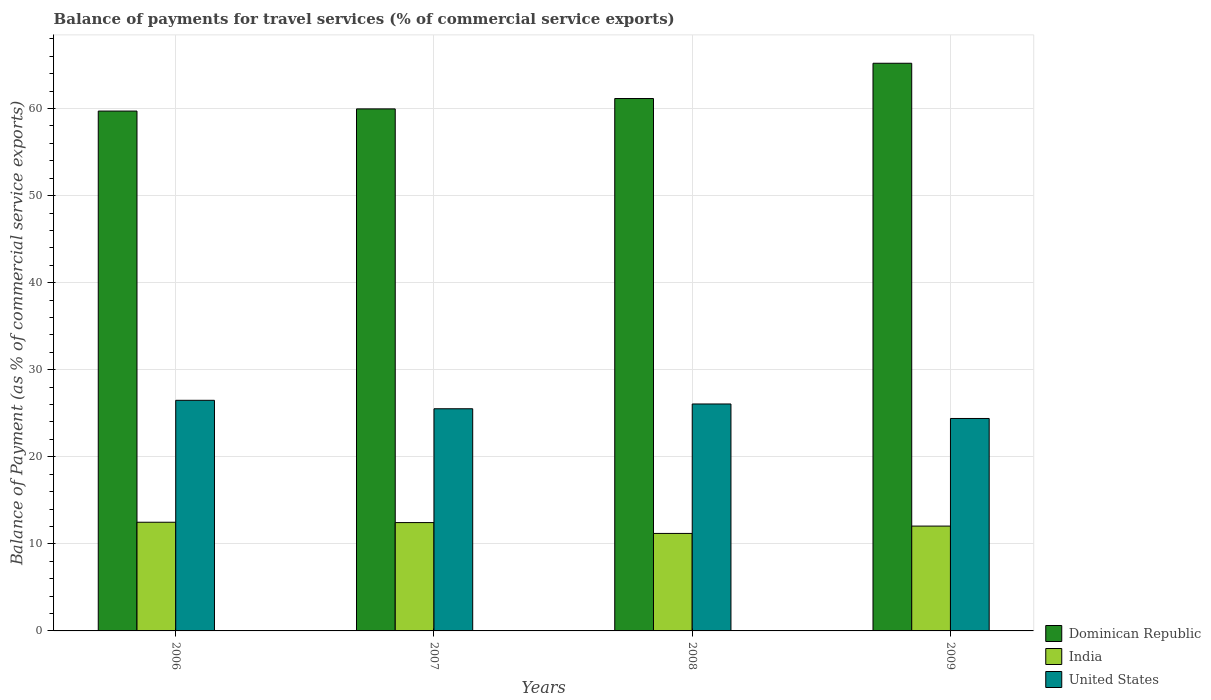How many groups of bars are there?
Provide a succinct answer. 4. How many bars are there on the 1st tick from the left?
Provide a succinct answer. 3. In how many cases, is the number of bars for a given year not equal to the number of legend labels?
Make the answer very short. 0. What is the balance of payments for travel services in United States in 2009?
Your answer should be very brief. 24.4. Across all years, what is the maximum balance of payments for travel services in Dominican Republic?
Provide a short and direct response. 65.2. Across all years, what is the minimum balance of payments for travel services in United States?
Keep it short and to the point. 24.4. In which year was the balance of payments for travel services in Dominican Republic maximum?
Offer a terse response. 2009. What is the total balance of payments for travel services in India in the graph?
Offer a very short reply. 48.16. What is the difference between the balance of payments for travel services in Dominican Republic in 2006 and that in 2008?
Keep it short and to the point. -1.44. What is the difference between the balance of payments for travel services in India in 2008 and the balance of payments for travel services in Dominican Republic in 2007?
Offer a very short reply. -48.76. What is the average balance of payments for travel services in Dominican Republic per year?
Your response must be concise. 61.5. In the year 2008, what is the difference between the balance of payments for travel services in United States and balance of payments for travel services in India?
Give a very brief answer. 14.87. What is the ratio of the balance of payments for travel services in India in 2006 to that in 2009?
Your answer should be compact. 1.04. Is the balance of payments for travel services in India in 2006 less than that in 2007?
Your answer should be compact. No. Is the difference between the balance of payments for travel services in United States in 2008 and 2009 greater than the difference between the balance of payments for travel services in India in 2008 and 2009?
Offer a terse response. Yes. What is the difference between the highest and the second highest balance of payments for travel services in India?
Ensure brevity in your answer.  0.04. What is the difference between the highest and the lowest balance of payments for travel services in India?
Give a very brief answer. 1.29. Is the sum of the balance of payments for travel services in India in 2006 and 2008 greater than the maximum balance of payments for travel services in Dominican Republic across all years?
Ensure brevity in your answer.  No. Is it the case that in every year, the sum of the balance of payments for travel services in India and balance of payments for travel services in United States is greater than the balance of payments for travel services in Dominican Republic?
Keep it short and to the point. No. Are all the bars in the graph horizontal?
Make the answer very short. No. How many years are there in the graph?
Offer a very short reply. 4. What is the difference between two consecutive major ticks on the Y-axis?
Offer a terse response. 10. Does the graph contain any zero values?
Your answer should be compact. No. How are the legend labels stacked?
Your answer should be very brief. Vertical. What is the title of the graph?
Offer a terse response. Balance of payments for travel services (% of commercial service exports). What is the label or title of the X-axis?
Offer a very short reply. Years. What is the label or title of the Y-axis?
Make the answer very short. Balance of Payment (as % of commercial service exports). What is the Balance of Payment (as % of commercial service exports) of Dominican Republic in 2006?
Provide a succinct answer. 59.71. What is the Balance of Payment (as % of commercial service exports) in India in 2006?
Offer a terse response. 12.48. What is the Balance of Payment (as % of commercial service exports) in United States in 2006?
Keep it short and to the point. 26.49. What is the Balance of Payment (as % of commercial service exports) in Dominican Republic in 2007?
Provide a short and direct response. 59.96. What is the Balance of Payment (as % of commercial service exports) of India in 2007?
Keep it short and to the point. 12.44. What is the Balance of Payment (as % of commercial service exports) in United States in 2007?
Keep it short and to the point. 25.52. What is the Balance of Payment (as % of commercial service exports) of Dominican Republic in 2008?
Your answer should be very brief. 61.15. What is the Balance of Payment (as % of commercial service exports) of India in 2008?
Provide a short and direct response. 11.2. What is the Balance of Payment (as % of commercial service exports) in United States in 2008?
Provide a short and direct response. 26.07. What is the Balance of Payment (as % of commercial service exports) of Dominican Republic in 2009?
Provide a succinct answer. 65.2. What is the Balance of Payment (as % of commercial service exports) in India in 2009?
Ensure brevity in your answer.  12.04. What is the Balance of Payment (as % of commercial service exports) in United States in 2009?
Keep it short and to the point. 24.4. Across all years, what is the maximum Balance of Payment (as % of commercial service exports) in Dominican Republic?
Provide a short and direct response. 65.2. Across all years, what is the maximum Balance of Payment (as % of commercial service exports) of India?
Give a very brief answer. 12.48. Across all years, what is the maximum Balance of Payment (as % of commercial service exports) of United States?
Make the answer very short. 26.49. Across all years, what is the minimum Balance of Payment (as % of commercial service exports) of Dominican Republic?
Make the answer very short. 59.71. Across all years, what is the minimum Balance of Payment (as % of commercial service exports) in India?
Your answer should be compact. 11.2. Across all years, what is the minimum Balance of Payment (as % of commercial service exports) in United States?
Provide a succinct answer. 24.4. What is the total Balance of Payment (as % of commercial service exports) in Dominican Republic in the graph?
Offer a terse response. 246.01. What is the total Balance of Payment (as % of commercial service exports) in India in the graph?
Make the answer very short. 48.16. What is the total Balance of Payment (as % of commercial service exports) in United States in the graph?
Give a very brief answer. 102.47. What is the difference between the Balance of Payment (as % of commercial service exports) of Dominican Republic in 2006 and that in 2007?
Your response must be concise. -0.25. What is the difference between the Balance of Payment (as % of commercial service exports) in India in 2006 and that in 2007?
Keep it short and to the point. 0.04. What is the difference between the Balance of Payment (as % of commercial service exports) of United States in 2006 and that in 2007?
Your answer should be compact. 0.97. What is the difference between the Balance of Payment (as % of commercial service exports) in Dominican Republic in 2006 and that in 2008?
Your answer should be very brief. -1.44. What is the difference between the Balance of Payment (as % of commercial service exports) of India in 2006 and that in 2008?
Ensure brevity in your answer.  1.29. What is the difference between the Balance of Payment (as % of commercial service exports) of United States in 2006 and that in 2008?
Offer a terse response. 0.42. What is the difference between the Balance of Payment (as % of commercial service exports) in Dominican Republic in 2006 and that in 2009?
Your answer should be compact. -5.49. What is the difference between the Balance of Payment (as % of commercial service exports) in India in 2006 and that in 2009?
Provide a succinct answer. 0.44. What is the difference between the Balance of Payment (as % of commercial service exports) in United States in 2006 and that in 2009?
Keep it short and to the point. 2.09. What is the difference between the Balance of Payment (as % of commercial service exports) of Dominican Republic in 2007 and that in 2008?
Your answer should be very brief. -1.19. What is the difference between the Balance of Payment (as % of commercial service exports) in India in 2007 and that in 2008?
Offer a very short reply. 1.24. What is the difference between the Balance of Payment (as % of commercial service exports) in United States in 2007 and that in 2008?
Offer a very short reply. -0.55. What is the difference between the Balance of Payment (as % of commercial service exports) in Dominican Republic in 2007 and that in 2009?
Your answer should be compact. -5.24. What is the difference between the Balance of Payment (as % of commercial service exports) in India in 2007 and that in 2009?
Ensure brevity in your answer.  0.4. What is the difference between the Balance of Payment (as % of commercial service exports) of United States in 2007 and that in 2009?
Keep it short and to the point. 1.12. What is the difference between the Balance of Payment (as % of commercial service exports) of Dominican Republic in 2008 and that in 2009?
Your response must be concise. -4.05. What is the difference between the Balance of Payment (as % of commercial service exports) of India in 2008 and that in 2009?
Your answer should be very brief. -0.84. What is the difference between the Balance of Payment (as % of commercial service exports) in United States in 2008 and that in 2009?
Keep it short and to the point. 1.67. What is the difference between the Balance of Payment (as % of commercial service exports) of Dominican Republic in 2006 and the Balance of Payment (as % of commercial service exports) of India in 2007?
Offer a very short reply. 47.27. What is the difference between the Balance of Payment (as % of commercial service exports) in Dominican Republic in 2006 and the Balance of Payment (as % of commercial service exports) in United States in 2007?
Your response must be concise. 34.19. What is the difference between the Balance of Payment (as % of commercial service exports) of India in 2006 and the Balance of Payment (as % of commercial service exports) of United States in 2007?
Provide a succinct answer. -13.03. What is the difference between the Balance of Payment (as % of commercial service exports) in Dominican Republic in 2006 and the Balance of Payment (as % of commercial service exports) in India in 2008?
Provide a short and direct response. 48.51. What is the difference between the Balance of Payment (as % of commercial service exports) of Dominican Republic in 2006 and the Balance of Payment (as % of commercial service exports) of United States in 2008?
Ensure brevity in your answer.  33.64. What is the difference between the Balance of Payment (as % of commercial service exports) of India in 2006 and the Balance of Payment (as % of commercial service exports) of United States in 2008?
Keep it short and to the point. -13.58. What is the difference between the Balance of Payment (as % of commercial service exports) of Dominican Republic in 2006 and the Balance of Payment (as % of commercial service exports) of India in 2009?
Ensure brevity in your answer.  47.67. What is the difference between the Balance of Payment (as % of commercial service exports) in Dominican Republic in 2006 and the Balance of Payment (as % of commercial service exports) in United States in 2009?
Offer a very short reply. 35.31. What is the difference between the Balance of Payment (as % of commercial service exports) of India in 2006 and the Balance of Payment (as % of commercial service exports) of United States in 2009?
Your answer should be compact. -11.92. What is the difference between the Balance of Payment (as % of commercial service exports) of Dominican Republic in 2007 and the Balance of Payment (as % of commercial service exports) of India in 2008?
Give a very brief answer. 48.76. What is the difference between the Balance of Payment (as % of commercial service exports) of Dominican Republic in 2007 and the Balance of Payment (as % of commercial service exports) of United States in 2008?
Your response must be concise. 33.89. What is the difference between the Balance of Payment (as % of commercial service exports) in India in 2007 and the Balance of Payment (as % of commercial service exports) in United States in 2008?
Give a very brief answer. -13.62. What is the difference between the Balance of Payment (as % of commercial service exports) in Dominican Republic in 2007 and the Balance of Payment (as % of commercial service exports) in India in 2009?
Provide a succinct answer. 47.92. What is the difference between the Balance of Payment (as % of commercial service exports) of Dominican Republic in 2007 and the Balance of Payment (as % of commercial service exports) of United States in 2009?
Ensure brevity in your answer.  35.56. What is the difference between the Balance of Payment (as % of commercial service exports) in India in 2007 and the Balance of Payment (as % of commercial service exports) in United States in 2009?
Offer a very short reply. -11.96. What is the difference between the Balance of Payment (as % of commercial service exports) in Dominican Republic in 2008 and the Balance of Payment (as % of commercial service exports) in India in 2009?
Offer a terse response. 49.11. What is the difference between the Balance of Payment (as % of commercial service exports) of Dominican Republic in 2008 and the Balance of Payment (as % of commercial service exports) of United States in 2009?
Keep it short and to the point. 36.75. What is the difference between the Balance of Payment (as % of commercial service exports) in India in 2008 and the Balance of Payment (as % of commercial service exports) in United States in 2009?
Your answer should be very brief. -13.2. What is the average Balance of Payment (as % of commercial service exports) in Dominican Republic per year?
Provide a short and direct response. 61.5. What is the average Balance of Payment (as % of commercial service exports) in India per year?
Keep it short and to the point. 12.04. What is the average Balance of Payment (as % of commercial service exports) of United States per year?
Your response must be concise. 25.62. In the year 2006, what is the difference between the Balance of Payment (as % of commercial service exports) of Dominican Republic and Balance of Payment (as % of commercial service exports) of India?
Offer a very short reply. 47.22. In the year 2006, what is the difference between the Balance of Payment (as % of commercial service exports) in Dominican Republic and Balance of Payment (as % of commercial service exports) in United States?
Your response must be concise. 33.22. In the year 2006, what is the difference between the Balance of Payment (as % of commercial service exports) in India and Balance of Payment (as % of commercial service exports) in United States?
Offer a terse response. -14. In the year 2007, what is the difference between the Balance of Payment (as % of commercial service exports) of Dominican Republic and Balance of Payment (as % of commercial service exports) of India?
Your answer should be very brief. 47.52. In the year 2007, what is the difference between the Balance of Payment (as % of commercial service exports) in Dominican Republic and Balance of Payment (as % of commercial service exports) in United States?
Give a very brief answer. 34.44. In the year 2007, what is the difference between the Balance of Payment (as % of commercial service exports) in India and Balance of Payment (as % of commercial service exports) in United States?
Make the answer very short. -13.07. In the year 2008, what is the difference between the Balance of Payment (as % of commercial service exports) of Dominican Republic and Balance of Payment (as % of commercial service exports) of India?
Your answer should be compact. 49.95. In the year 2008, what is the difference between the Balance of Payment (as % of commercial service exports) in Dominican Republic and Balance of Payment (as % of commercial service exports) in United States?
Ensure brevity in your answer.  35.08. In the year 2008, what is the difference between the Balance of Payment (as % of commercial service exports) in India and Balance of Payment (as % of commercial service exports) in United States?
Your answer should be very brief. -14.87. In the year 2009, what is the difference between the Balance of Payment (as % of commercial service exports) in Dominican Republic and Balance of Payment (as % of commercial service exports) in India?
Your response must be concise. 53.16. In the year 2009, what is the difference between the Balance of Payment (as % of commercial service exports) of Dominican Republic and Balance of Payment (as % of commercial service exports) of United States?
Offer a very short reply. 40.8. In the year 2009, what is the difference between the Balance of Payment (as % of commercial service exports) in India and Balance of Payment (as % of commercial service exports) in United States?
Keep it short and to the point. -12.36. What is the ratio of the Balance of Payment (as % of commercial service exports) in Dominican Republic in 2006 to that in 2007?
Offer a terse response. 1. What is the ratio of the Balance of Payment (as % of commercial service exports) of India in 2006 to that in 2007?
Offer a terse response. 1. What is the ratio of the Balance of Payment (as % of commercial service exports) of United States in 2006 to that in 2007?
Give a very brief answer. 1.04. What is the ratio of the Balance of Payment (as % of commercial service exports) of Dominican Republic in 2006 to that in 2008?
Offer a very short reply. 0.98. What is the ratio of the Balance of Payment (as % of commercial service exports) of India in 2006 to that in 2008?
Keep it short and to the point. 1.11. What is the ratio of the Balance of Payment (as % of commercial service exports) of United States in 2006 to that in 2008?
Offer a terse response. 1.02. What is the ratio of the Balance of Payment (as % of commercial service exports) of Dominican Republic in 2006 to that in 2009?
Provide a succinct answer. 0.92. What is the ratio of the Balance of Payment (as % of commercial service exports) in India in 2006 to that in 2009?
Ensure brevity in your answer.  1.04. What is the ratio of the Balance of Payment (as % of commercial service exports) in United States in 2006 to that in 2009?
Your response must be concise. 1.09. What is the ratio of the Balance of Payment (as % of commercial service exports) in Dominican Republic in 2007 to that in 2008?
Provide a succinct answer. 0.98. What is the ratio of the Balance of Payment (as % of commercial service exports) of India in 2007 to that in 2008?
Your answer should be compact. 1.11. What is the ratio of the Balance of Payment (as % of commercial service exports) in United States in 2007 to that in 2008?
Ensure brevity in your answer.  0.98. What is the ratio of the Balance of Payment (as % of commercial service exports) of Dominican Republic in 2007 to that in 2009?
Provide a succinct answer. 0.92. What is the ratio of the Balance of Payment (as % of commercial service exports) of India in 2007 to that in 2009?
Provide a short and direct response. 1.03. What is the ratio of the Balance of Payment (as % of commercial service exports) of United States in 2007 to that in 2009?
Offer a very short reply. 1.05. What is the ratio of the Balance of Payment (as % of commercial service exports) of Dominican Republic in 2008 to that in 2009?
Offer a terse response. 0.94. What is the ratio of the Balance of Payment (as % of commercial service exports) in India in 2008 to that in 2009?
Your answer should be compact. 0.93. What is the ratio of the Balance of Payment (as % of commercial service exports) of United States in 2008 to that in 2009?
Keep it short and to the point. 1.07. What is the difference between the highest and the second highest Balance of Payment (as % of commercial service exports) of Dominican Republic?
Ensure brevity in your answer.  4.05. What is the difference between the highest and the second highest Balance of Payment (as % of commercial service exports) in India?
Offer a terse response. 0.04. What is the difference between the highest and the second highest Balance of Payment (as % of commercial service exports) of United States?
Provide a succinct answer. 0.42. What is the difference between the highest and the lowest Balance of Payment (as % of commercial service exports) in Dominican Republic?
Give a very brief answer. 5.49. What is the difference between the highest and the lowest Balance of Payment (as % of commercial service exports) of India?
Offer a terse response. 1.29. What is the difference between the highest and the lowest Balance of Payment (as % of commercial service exports) in United States?
Your answer should be compact. 2.09. 